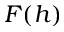<formula> <loc_0><loc_0><loc_500><loc_500>F ( h )</formula> 